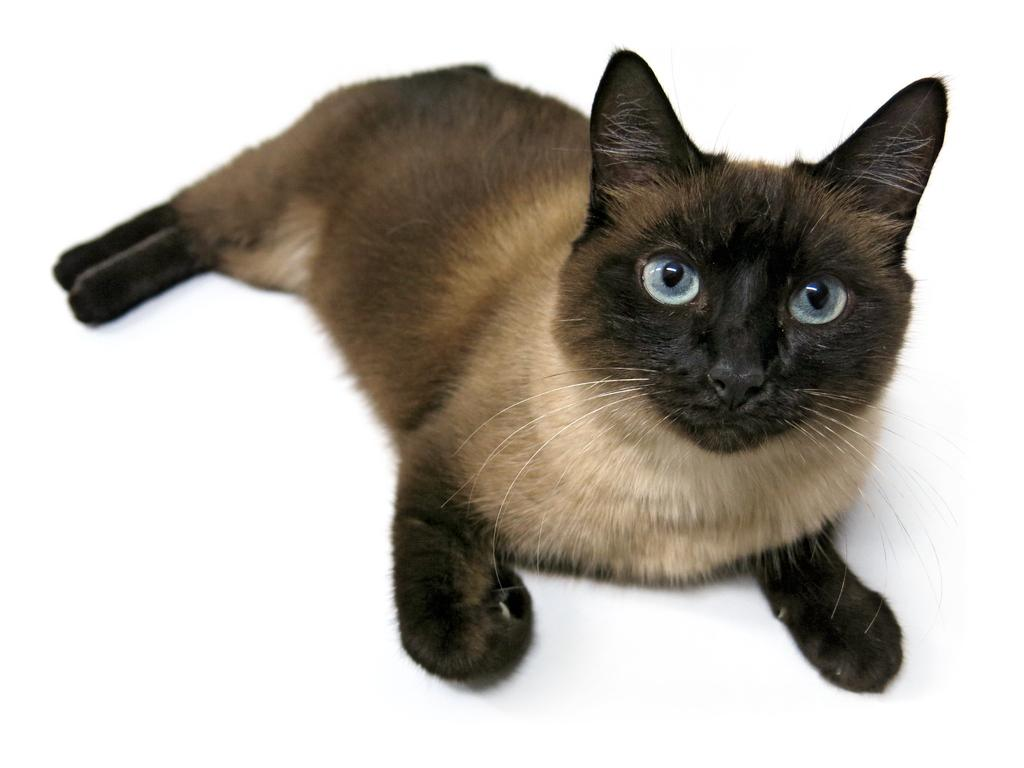What type of animal is in the image? There is a cat in the image. What is the cat laying on? The cat is laying on a white surface. What is the cat looking at? The cat is looking at a picture. What songs is the cat singing in the image? Cats do not sing songs, so there are no songs being sung by the cat in the image. 